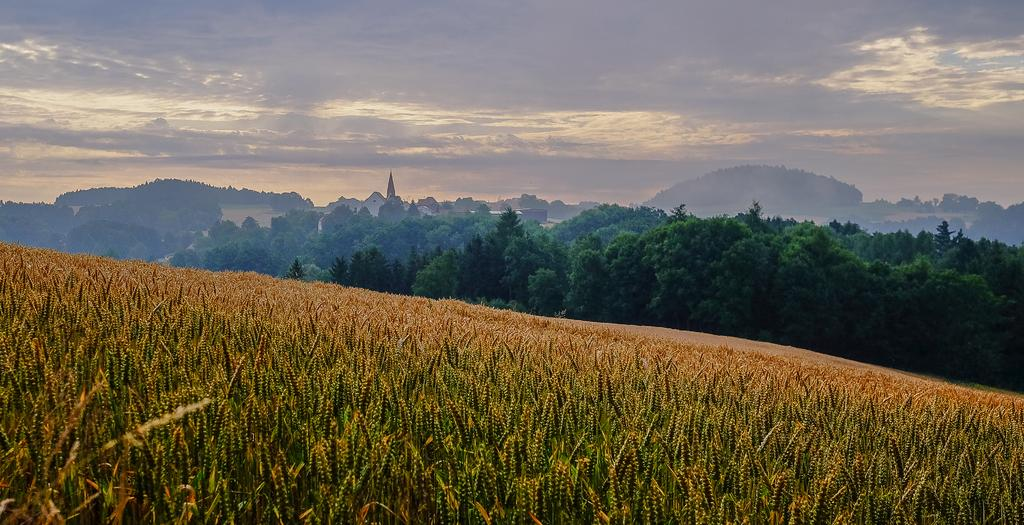What can be seen in the sky in the image? The sky with clouds is visible in the image. What type of natural elements are present in the image? There are trees in the image. What man-made structures can be seen in the image? There are buildings in the image. What type of land use is depicted in the image? An agricultural farm is present in the image. What type of sweater is being worn by the tree in the image? There are no people or clothing items present in the image, so the concept of a sweater being worn by a tree is not applicable. 